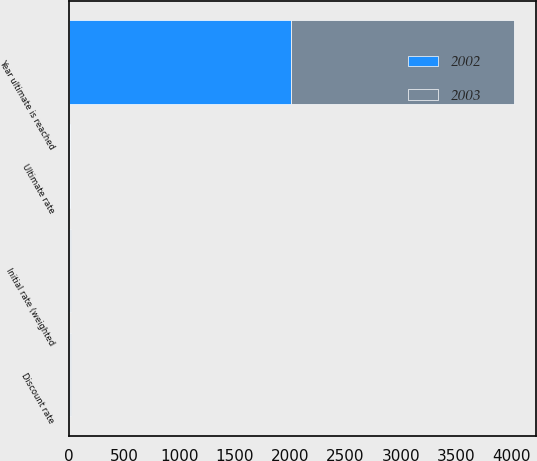Convert chart. <chart><loc_0><loc_0><loc_500><loc_500><stacked_bar_chart><ecel><fcel>Discount rate<fcel>Initial rate (weighted<fcel>Year ultimate is reached<fcel>Ultimate rate<nl><fcel>2003<fcel>6.25<fcel>10<fcel>2012<fcel>5.5<nl><fcel>2002<fcel>6.75<fcel>10<fcel>2012<fcel>5.5<nl></chart> 